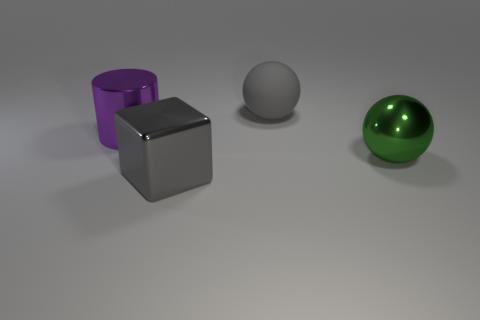There is a cube that is the same color as the big rubber sphere; what is its material?
Provide a short and direct response. Metal. Is the number of purple metal cylinders greater than the number of small green metal objects?
Provide a short and direct response. Yes. There is a object on the right side of the large sphere behind the purple cylinder behind the shiny ball; what is its color?
Ensure brevity in your answer.  Green. There is a ball that is made of the same material as the big block; what color is it?
Offer a terse response. Green. Are there any other things that have the same size as the gray shiny object?
Keep it short and to the point. Yes. How many objects are large gray things that are on the right side of the large cube or big objects that are on the left side of the big rubber object?
Offer a very short reply. 3. Does the gray thing in front of the matte thing have the same size as the ball that is in front of the purple object?
Your response must be concise. Yes. There is another thing that is the same shape as the big rubber thing; what color is it?
Offer a very short reply. Green. Are there any other things that are the same shape as the purple object?
Provide a short and direct response. No. Are there more big gray metal cubes to the right of the big metal ball than metal spheres that are to the right of the rubber ball?
Keep it short and to the point. No. 